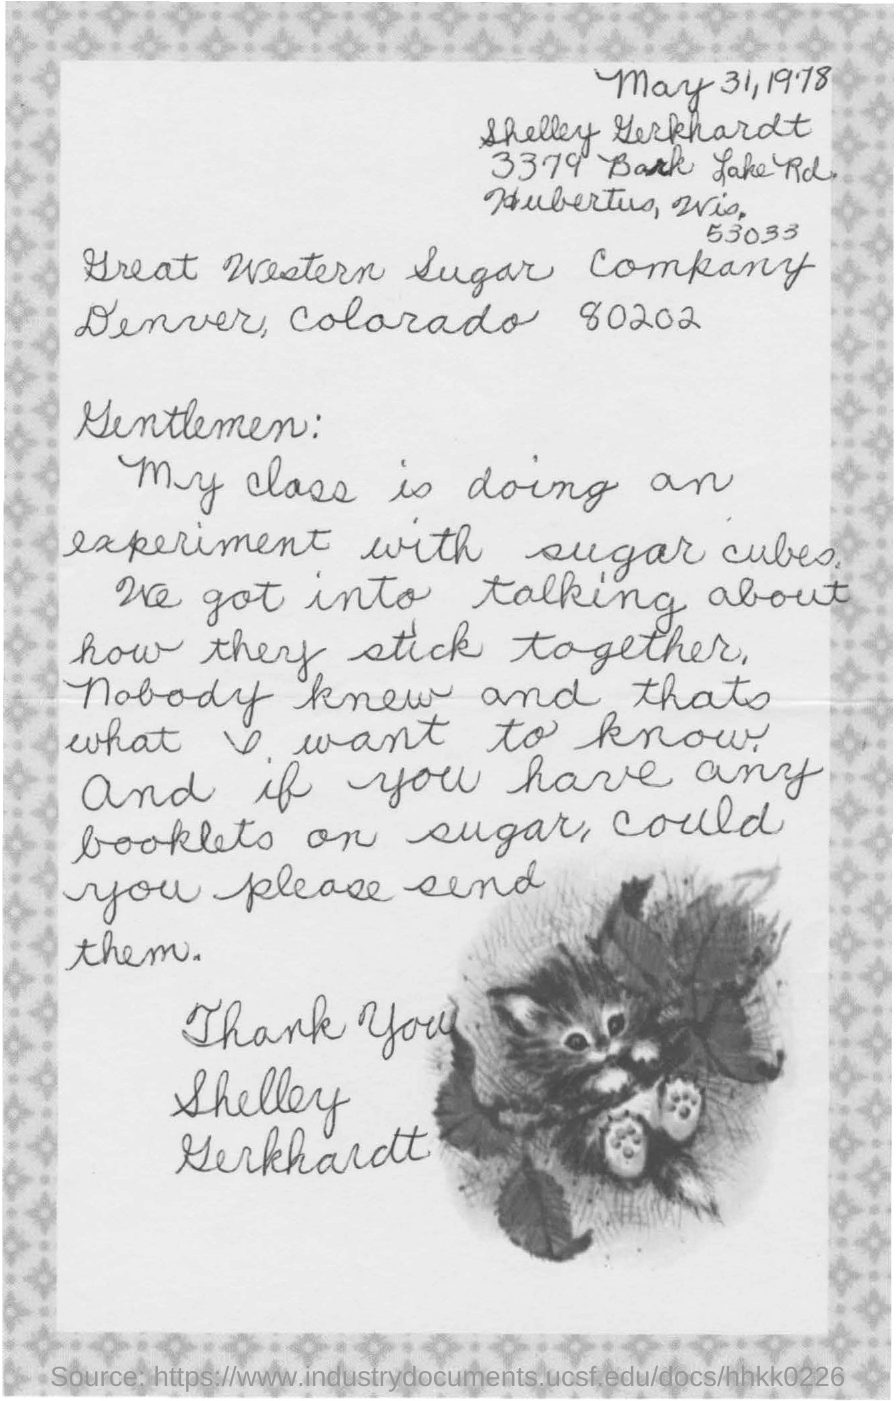Indicate a few pertinent items in this graphic. The class is currently engaged in experiments involving sugar cubes. The letter is written by Shelley Gerkhardt. 